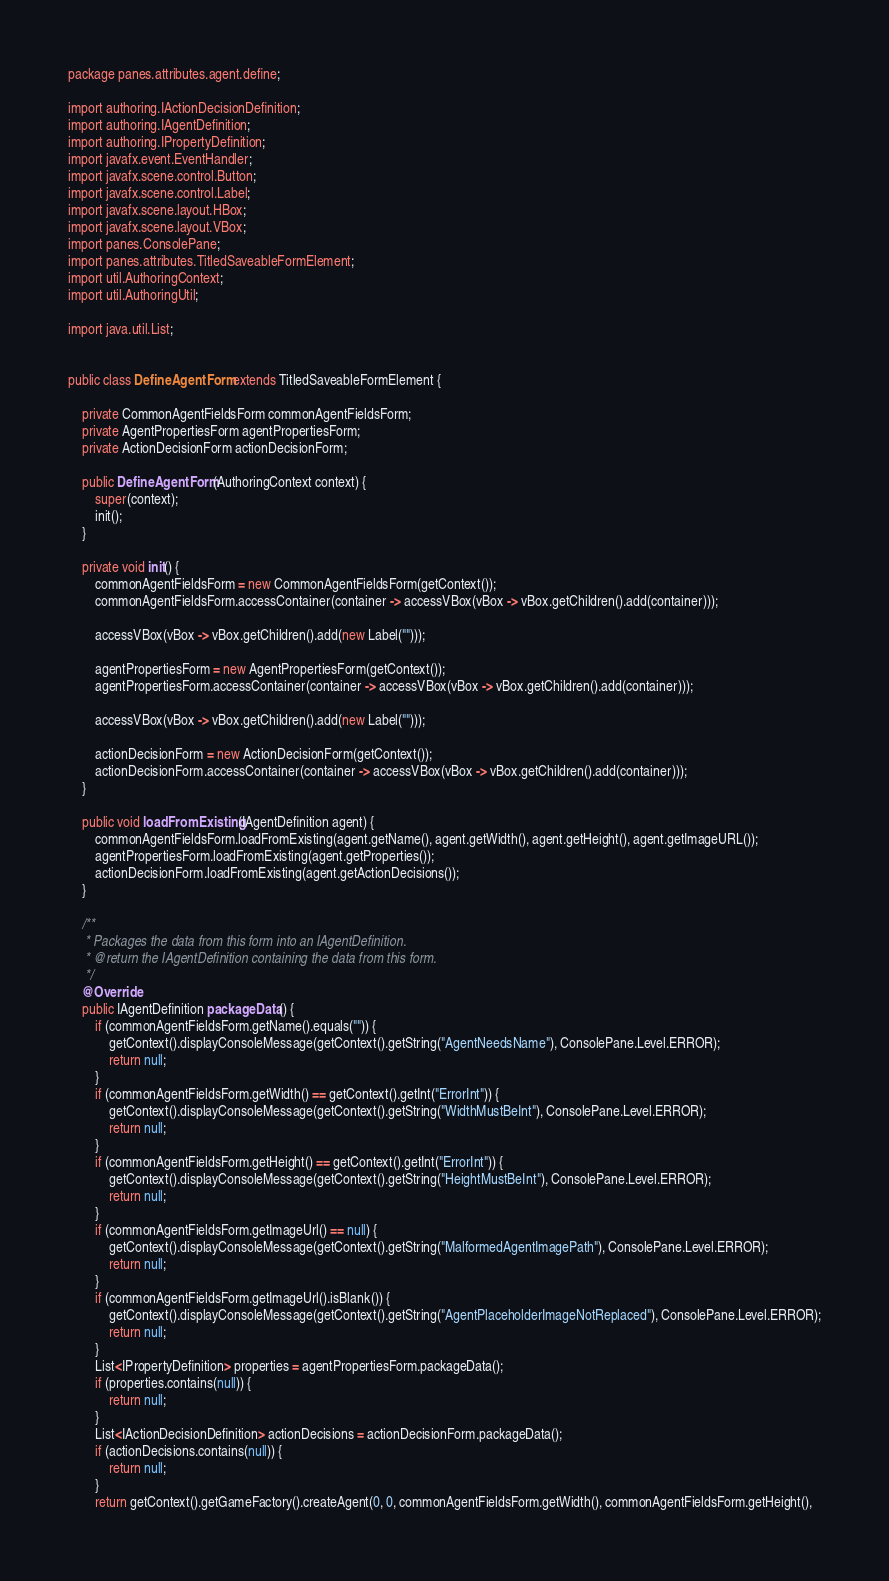<code> <loc_0><loc_0><loc_500><loc_500><_Java_>package panes.attributes.agent.define;

import authoring.IActionDecisionDefinition;
import authoring.IAgentDefinition;
import authoring.IPropertyDefinition;
import javafx.event.EventHandler;
import javafx.scene.control.Button;
import javafx.scene.control.Label;
import javafx.scene.layout.HBox;
import javafx.scene.layout.VBox;
import panes.ConsolePane;
import panes.attributes.TitledSaveableFormElement;
import util.AuthoringContext;
import util.AuthoringUtil;

import java.util.List;


public class DefineAgentForm extends TitledSaveableFormElement {

    private CommonAgentFieldsForm commonAgentFieldsForm;
    private AgentPropertiesForm agentPropertiesForm;
    private ActionDecisionForm actionDecisionForm;

    public DefineAgentForm(AuthoringContext context) {
        super(context);
        init();
    }

    private void init() {
        commonAgentFieldsForm = new CommonAgentFieldsForm(getContext());
        commonAgentFieldsForm.accessContainer(container -> accessVBox(vBox -> vBox.getChildren().add(container)));

        accessVBox(vBox -> vBox.getChildren().add(new Label("")));

        agentPropertiesForm = new AgentPropertiesForm(getContext());
        agentPropertiesForm.accessContainer(container -> accessVBox(vBox -> vBox.getChildren().add(container)));

        accessVBox(vBox -> vBox.getChildren().add(new Label("")));

        actionDecisionForm = new ActionDecisionForm(getContext());
        actionDecisionForm.accessContainer(container -> accessVBox(vBox -> vBox.getChildren().add(container)));
    }

    public void loadFromExisting(IAgentDefinition agent) {
        commonAgentFieldsForm.loadFromExisting(agent.getName(), agent.getWidth(), agent.getHeight(), agent.getImageURL());
        agentPropertiesForm.loadFromExisting(agent.getProperties());
        actionDecisionForm.loadFromExisting(agent.getActionDecisions());
    }

    /**
     * Packages the data from this form into an IAgentDefinition.
     * @return the IAgentDefinition containing the data from this form.
     */
    @Override
    public IAgentDefinition packageData() {
        if (commonAgentFieldsForm.getName().equals("")) {
            getContext().displayConsoleMessage(getContext().getString("AgentNeedsName"), ConsolePane.Level.ERROR);
            return null;
        }
        if (commonAgentFieldsForm.getWidth() == getContext().getInt("ErrorInt")) {
            getContext().displayConsoleMessage(getContext().getString("WidthMustBeInt"), ConsolePane.Level.ERROR);
            return null;
        }
        if (commonAgentFieldsForm.getHeight() == getContext().getInt("ErrorInt")) {
            getContext().displayConsoleMessage(getContext().getString("HeightMustBeInt"), ConsolePane.Level.ERROR);
            return null;
        }
        if (commonAgentFieldsForm.getImageUrl() == null) {
            getContext().displayConsoleMessage(getContext().getString("MalformedAgentImagePath"), ConsolePane.Level.ERROR);
            return null;
        }
        if (commonAgentFieldsForm.getImageUrl().isBlank()) {
            getContext().displayConsoleMessage(getContext().getString("AgentPlaceholderImageNotReplaced"), ConsolePane.Level.ERROR);
            return null;
        }
        List<IPropertyDefinition> properties = agentPropertiesForm.packageData();
        if (properties.contains(null)) {
            return null;
        }
        List<IActionDecisionDefinition> actionDecisions = actionDecisionForm.packageData();
        if (actionDecisions.contains(null)) {
            return null;
        }
        return getContext().getGameFactory().createAgent(0, 0, commonAgentFieldsForm.getWidth(), commonAgentFieldsForm.getHeight(),</code> 